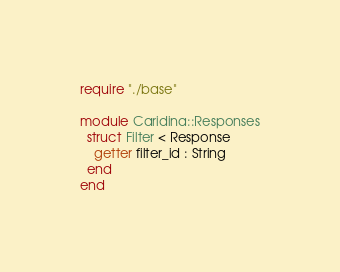Convert code to text. <code><loc_0><loc_0><loc_500><loc_500><_Crystal_>require "./base"

module Caridina::Responses
  struct Filter < Response
    getter filter_id : String
  end
end
</code> 